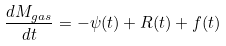<formula> <loc_0><loc_0><loc_500><loc_500>\frac { d M _ { g a s } } { d t } = - \psi ( t ) + R ( t ) + f ( t )</formula> 